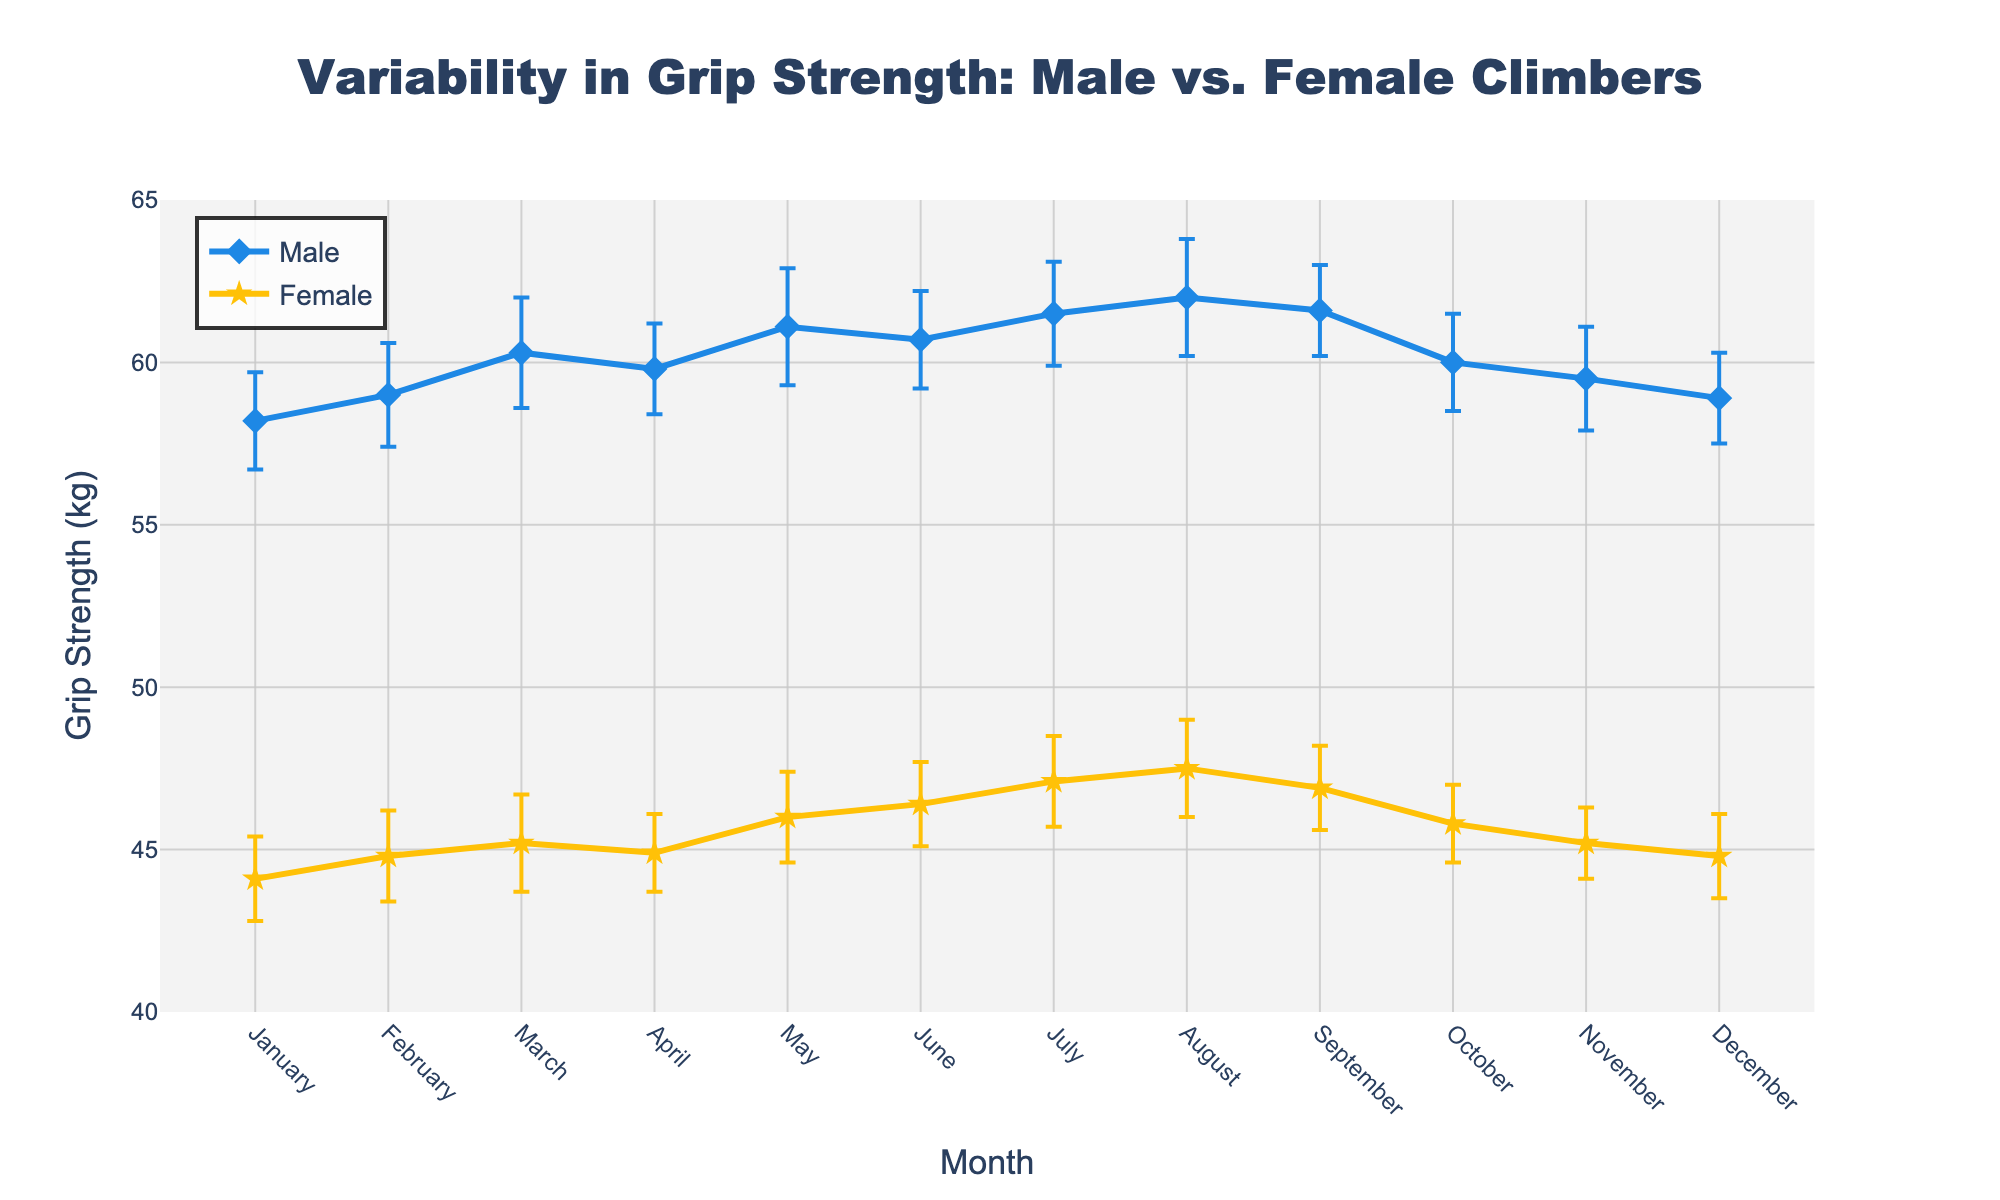How many data points are shown for each gender? The x-axis shows months from January to December, indicating there are 12 data points for male and 12 data points for female climbers.
Answer: 12 for each gender What is the title of the plot? The title of the plot is located at the top center of the figure. It reads "Variability in Grip Strength: Male vs. Female Climbers".
Answer: Variability in Grip Strength: Male vs. Female Climbers What is the color of the line representing male grip strength? The line corresponding to male grip strength is represented by the color blue. This line is clearly visible throughout the plot.
Answer: Blue In which month is the female grip strength the highest? By looking at the yellow line (representing female grip strength), the highest point appears in August, where the value reaches 47.5 kg.
Answer: August What is the difference in grip strength between males and females in March? The grip strength for males in March is 60.3 kg and for females is 45.2 kg. Subtracting female grip strength from male grip strength gives 60.3 - 45.2.
Answer: 15.1 kg Which gender has a greater variability in grip strength as indicated by the error bars? Examining the error bars, male climbers generally have higher standard error values, indicating greater variability in their grip strength measurements.
Answer: Male In which month is the gap between male and female grip strength the smallest? By comparing the differences month by month, the smallest gap appears in January, where the difference is 58.2 - 44.1 = 14.1 kg.
Answer: January What is the average male grip strength over the year? Add the monthly male grip strength values: (58.2 + 59.0 + 60.3 + 59.8 + 61.1 + 60.7 + 61.5 + 62.0 + 61.6 + 60.0 + 59.5 + 58.9) and divide by 12. This gives (722.6 / 12).
Answer: 60.22 kg Which month shows the highest standard error for male climbers? By comparing the error bars visually, the highest standard error for males is observed in both May and August, each with a standard error of 1.8.
Answer: May and August How does the female grip strength trend compare to the male grip strength trend over the year? Both male and female grip strengths follow a generally increasing trend from January to August, then slightly decrease towards the end of the year. However, males consistently have higher grip strength values than females.
Answer: Increasing until August, then decreasing 